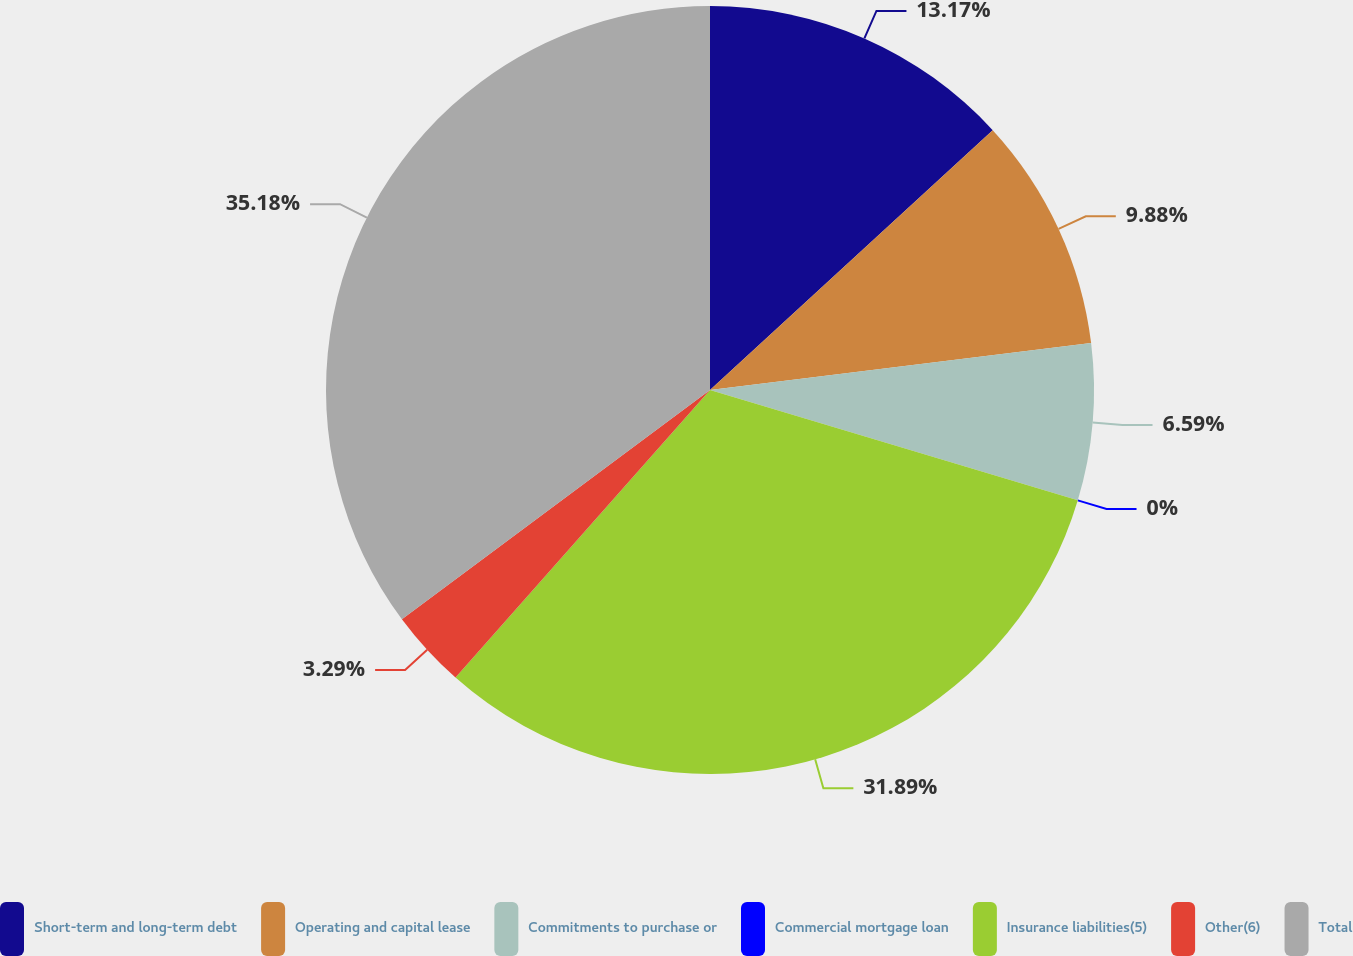Convert chart. <chart><loc_0><loc_0><loc_500><loc_500><pie_chart><fcel>Short-term and long-term debt<fcel>Operating and capital lease<fcel>Commitments to purchase or<fcel>Commercial mortgage loan<fcel>Insurance liabilities(5)<fcel>Other(6)<fcel>Total<nl><fcel>13.17%<fcel>9.88%<fcel>6.59%<fcel>0.0%<fcel>31.89%<fcel>3.29%<fcel>35.18%<nl></chart> 